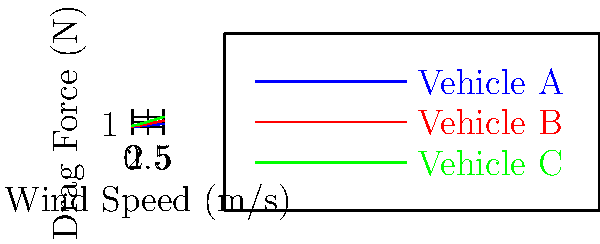As a PR agent for a musician who promotes eco-friendly transportation, you're preparing for a media appearance discussing vehicle aerodynamics. The graph shows drag force vs. wind speed for three vehicle shapes tested in a wind tunnel. Which vehicle shape would you recommend to emphasize fuel efficiency, and why? To answer this question, we need to analyze the drag coefficient of each vehicle shape based on the given wind tunnel data. The drag coefficient is proportional to the slope of each line on the graph. A lower slope indicates a lower drag coefficient and better aerodynamics.

Step 1: Observe the slopes of the lines for each vehicle.
- Vehicle A (blue line): Has the lowest slope
- Vehicle B (red line): Has a moderate slope
- Vehicle C (green line): Has the steepest slope

Step 2: Interpret the data in terms of drag coefficient.
- Vehicle A has the lowest drag coefficient, indicating the best aerodynamics.
- Vehicle B has a moderate drag coefficient.
- Vehicle C has the highest drag coefficient, indicating poor aerodynamics.

Step 3: Relate drag coefficient to fuel efficiency.
A lower drag coefficient means less energy is required to overcome air resistance, resulting in better fuel efficiency.

Step 4: Consider the PR perspective.
As a PR agent promoting eco-friendly transportation, you would want to emphasize the vehicle shape that offers the best fuel efficiency and lowest environmental impact.

Therefore, you should recommend Vehicle A, as it has the lowest drag coefficient and would likely be the most fuel-efficient option.
Answer: Vehicle A, due to its lowest drag coefficient indicated by the graph's shallowest slope, suggesting the best fuel efficiency. 